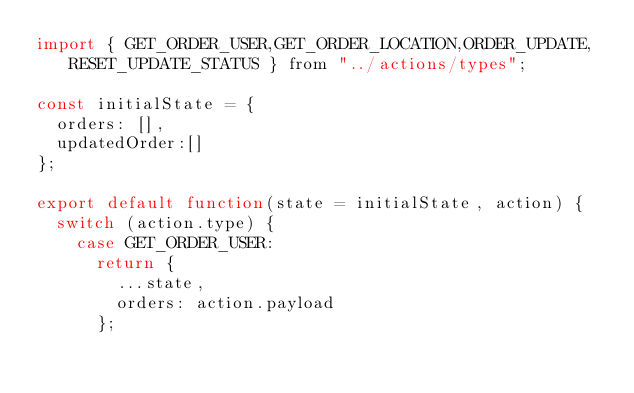<code> <loc_0><loc_0><loc_500><loc_500><_JavaScript_>import { GET_ORDER_USER,GET_ORDER_LOCATION,ORDER_UPDATE,RESET_UPDATE_STATUS } from "../actions/types";

const initialState = {
  orders: [], 
  updatedOrder:[]
};

export default function(state = initialState, action) {
  switch (action.type) {
    case GET_ORDER_USER:      
      return {
        ...state,
        orders: action.payload
      };   </code> 